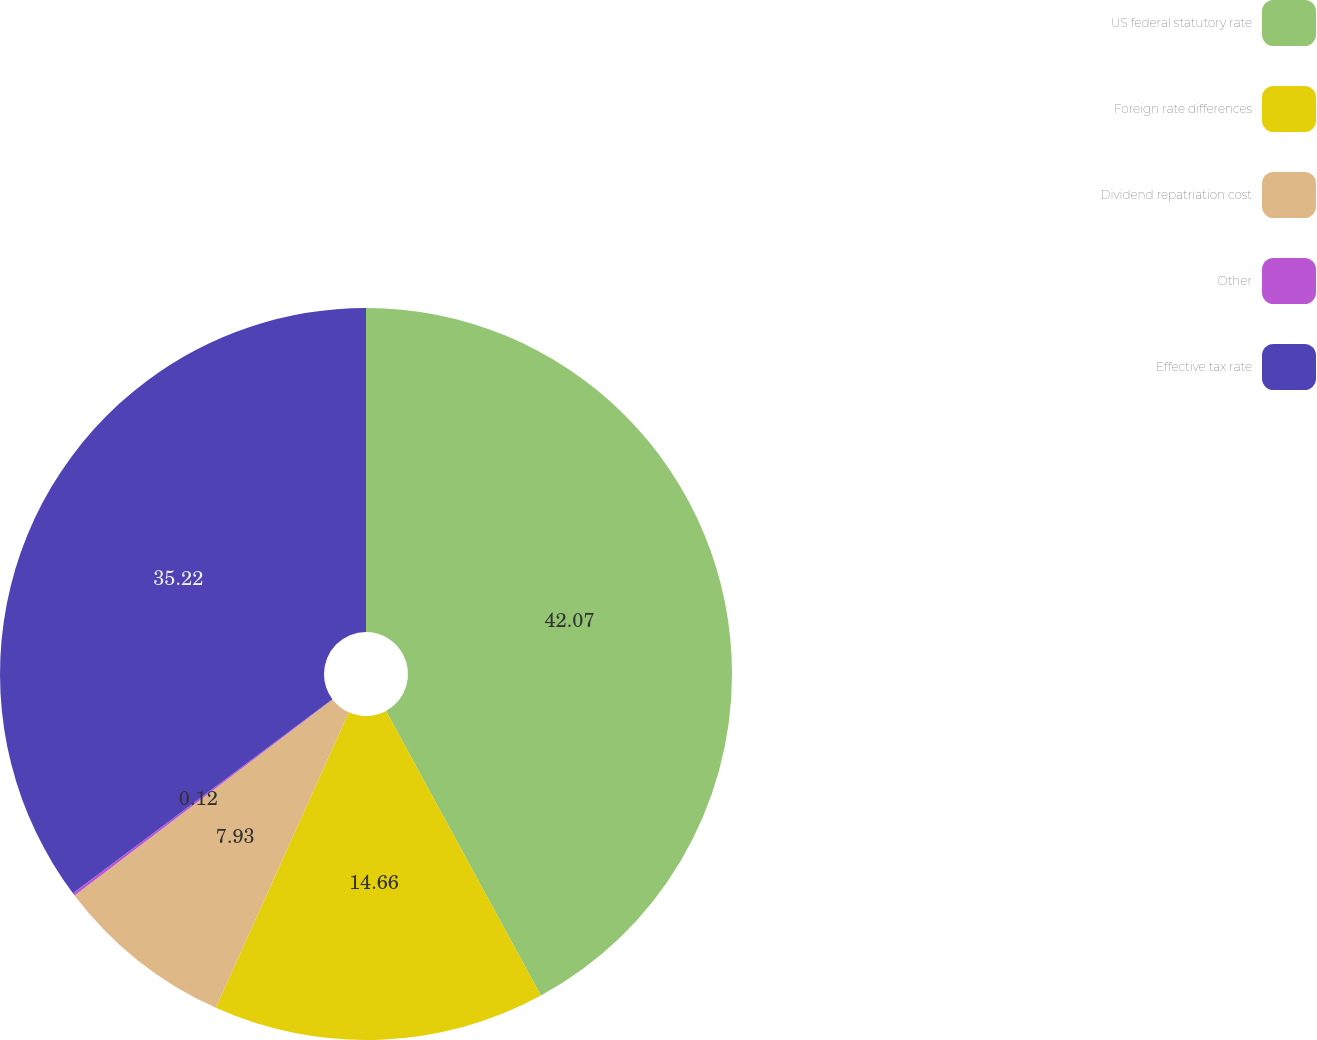Convert chart. <chart><loc_0><loc_0><loc_500><loc_500><pie_chart><fcel>US federal statutory rate<fcel>Foreign rate differences<fcel>Dividend repatriation cost<fcel>Other<fcel>Effective tax rate<nl><fcel>42.07%<fcel>14.66%<fcel>7.93%<fcel>0.12%<fcel>35.22%<nl></chart> 